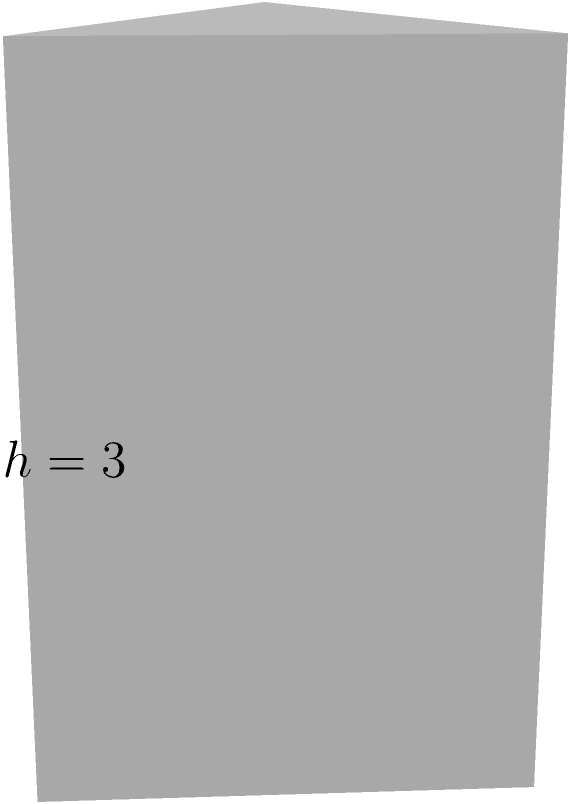As a marketing research expert analyzing spatial data for product placement, you encounter a scenario where you need to calculate the volume of a triangular display unit. The base of the unit is an equilateral triangle with an area of 1.732 square meters, and the height of the unit is 3 meters. Calculate the volume of this triangular prism-shaped display unit. To find the volume of a triangular prism, we use the formula:

$$V = A_b \cdot h$$

Where:
$V$ = Volume of the prism
$A_b$ = Area of the base (given as 1.732 square meters)
$h$ = Height of the prism (given as 3 meters)

Step 1: Identify the known values
$A_b = 1.732$ m²
$h = 3$ m

Step 2: Apply the volume formula
$$V = A_b \cdot h$$
$$V = 1.732 \cdot 3$$

Step 3: Calculate the result
$$V = 5.196 \text{ m}^3$$

Therefore, the volume of the triangular prism-shaped display unit is 5.196 cubic meters.
Answer: 5.196 m³ 